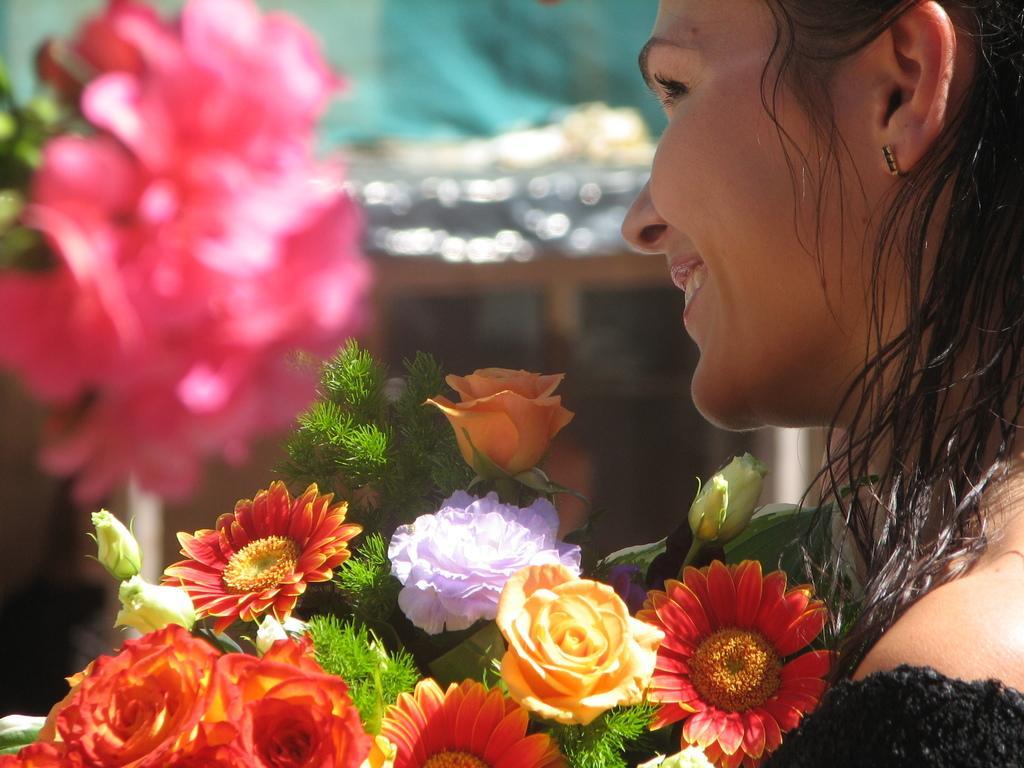Describe this image in one or two sentences. In this image, I can see a woman smiling and a bunch of colorful flowers. There is a blurred background. 